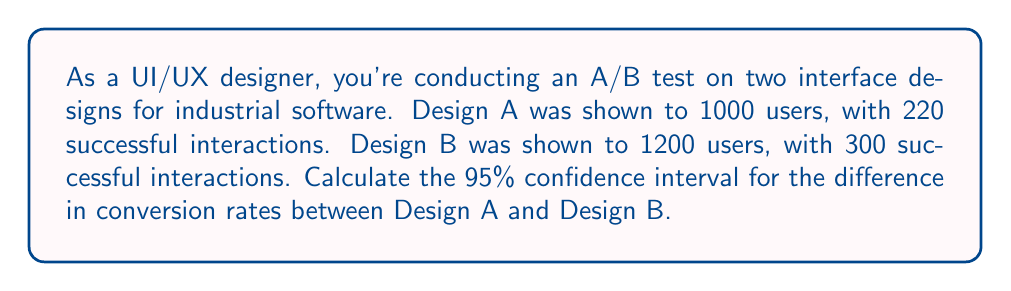Teach me how to tackle this problem. Let's approach this step-by-step:

1) First, calculate the conversion rates for each design:
   Design A: $p_A = 220/1000 = 0.22$
   Design B: $p_B = 300/1200 = 0.25$

2) The difference in conversion rates is:
   $\hat{p} = p_B - p_A = 0.25 - 0.22 = 0.03$

3) Calculate the standard error of the difference:
   $$SE = \sqrt{\frac{p_A(1-p_A)}{n_A} + \frac{p_B(1-p_B)}{n_B}}$$
   $$SE = \sqrt{\frac{0.22(1-0.22)}{1000} + \frac{0.25(1-0.25)}{1200}}$$
   $$SE = \sqrt{0.0001716 + 0.0001563} = \sqrt{0.0003279} = 0.0181$$

4) For a 95% confidence interval, use z = 1.96 (from the standard normal distribution)

5) Calculate the margin of error:
   $ME = z * SE = 1.96 * 0.0181 = 0.0355$

6) The confidence interval is:
   $(\hat{p} - ME, \hat{p} + ME) = (0.03 - 0.0355, 0.03 + 0.0355)$
   $= (-0.0055, 0.0655)$

Therefore, we can be 95% confident that the true difference in conversion rates between Design B and Design A falls between -0.55% and 6.55%.
Answer: (-0.0055, 0.0655) 